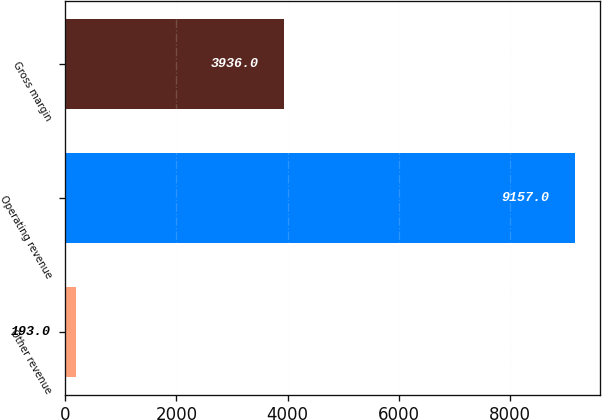Convert chart to OTSL. <chart><loc_0><loc_0><loc_500><loc_500><bar_chart><fcel>Other revenue<fcel>Operating revenue<fcel>Gross margin<nl><fcel>193<fcel>9157<fcel>3936<nl></chart> 